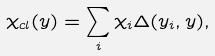Convert formula to latex. <formula><loc_0><loc_0><loc_500><loc_500>\chi _ { c l } ( y ) = \sum _ { i } \chi _ { i } \Delta ( y _ { i } , y ) ,</formula> 